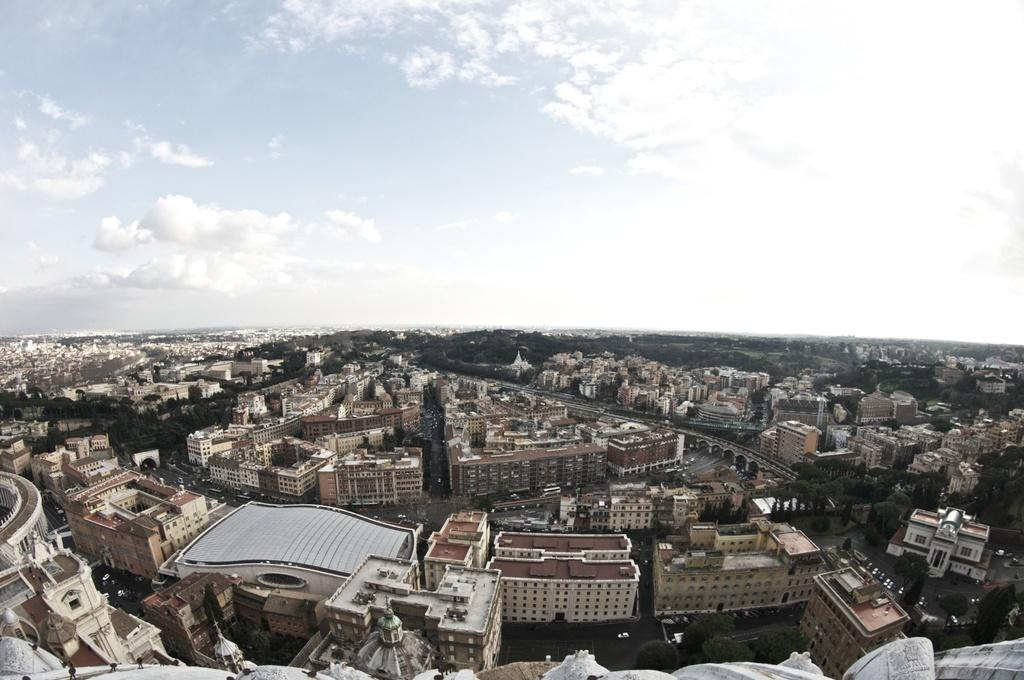What type of structures can be seen in the image? There are buildings in the image. What type of vegetation is present in the image? There are trees in the image. What is the condition of the sky in the image? The sky is cloudy in the image. What type of writing can be seen on the clouds in the image? There is no writing present on the clouds in the image. What is located behind the buildings in the image? The provided facts do not mention anything about what is located behind the buildings in the image. 